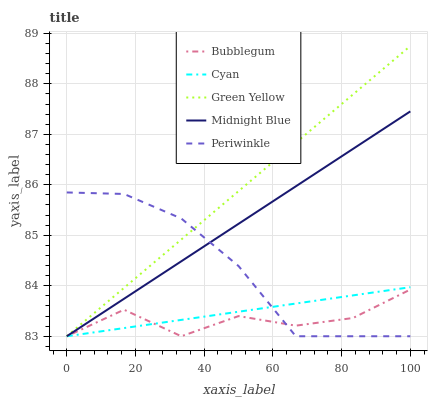Does Bubblegum have the minimum area under the curve?
Answer yes or no. Yes. Does Green Yellow have the maximum area under the curve?
Answer yes or no. Yes. Does Periwinkle have the minimum area under the curve?
Answer yes or no. No. Does Periwinkle have the maximum area under the curve?
Answer yes or no. No. Is Midnight Blue the smoothest?
Answer yes or no. Yes. Is Bubblegum the roughest?
Answer yes or no. Yes. Is Green Yellow the smoothest?
Answer yes or no. No. Is Green Yellow the roughest?
Answer yes or no. No. Does Green Yellow have the highest value?
Answer yes or no. Yes. Does Periwinkle have the highest value?
Answer yes or no. No. Does Midnight Blue intersect Cyan?
Answer yes or no. Yes. Is Midnight Blue less than Cyan?
Answer yes or no. No. Is Midnight Blue greater than Cyan?
Answer yes or no. No. 